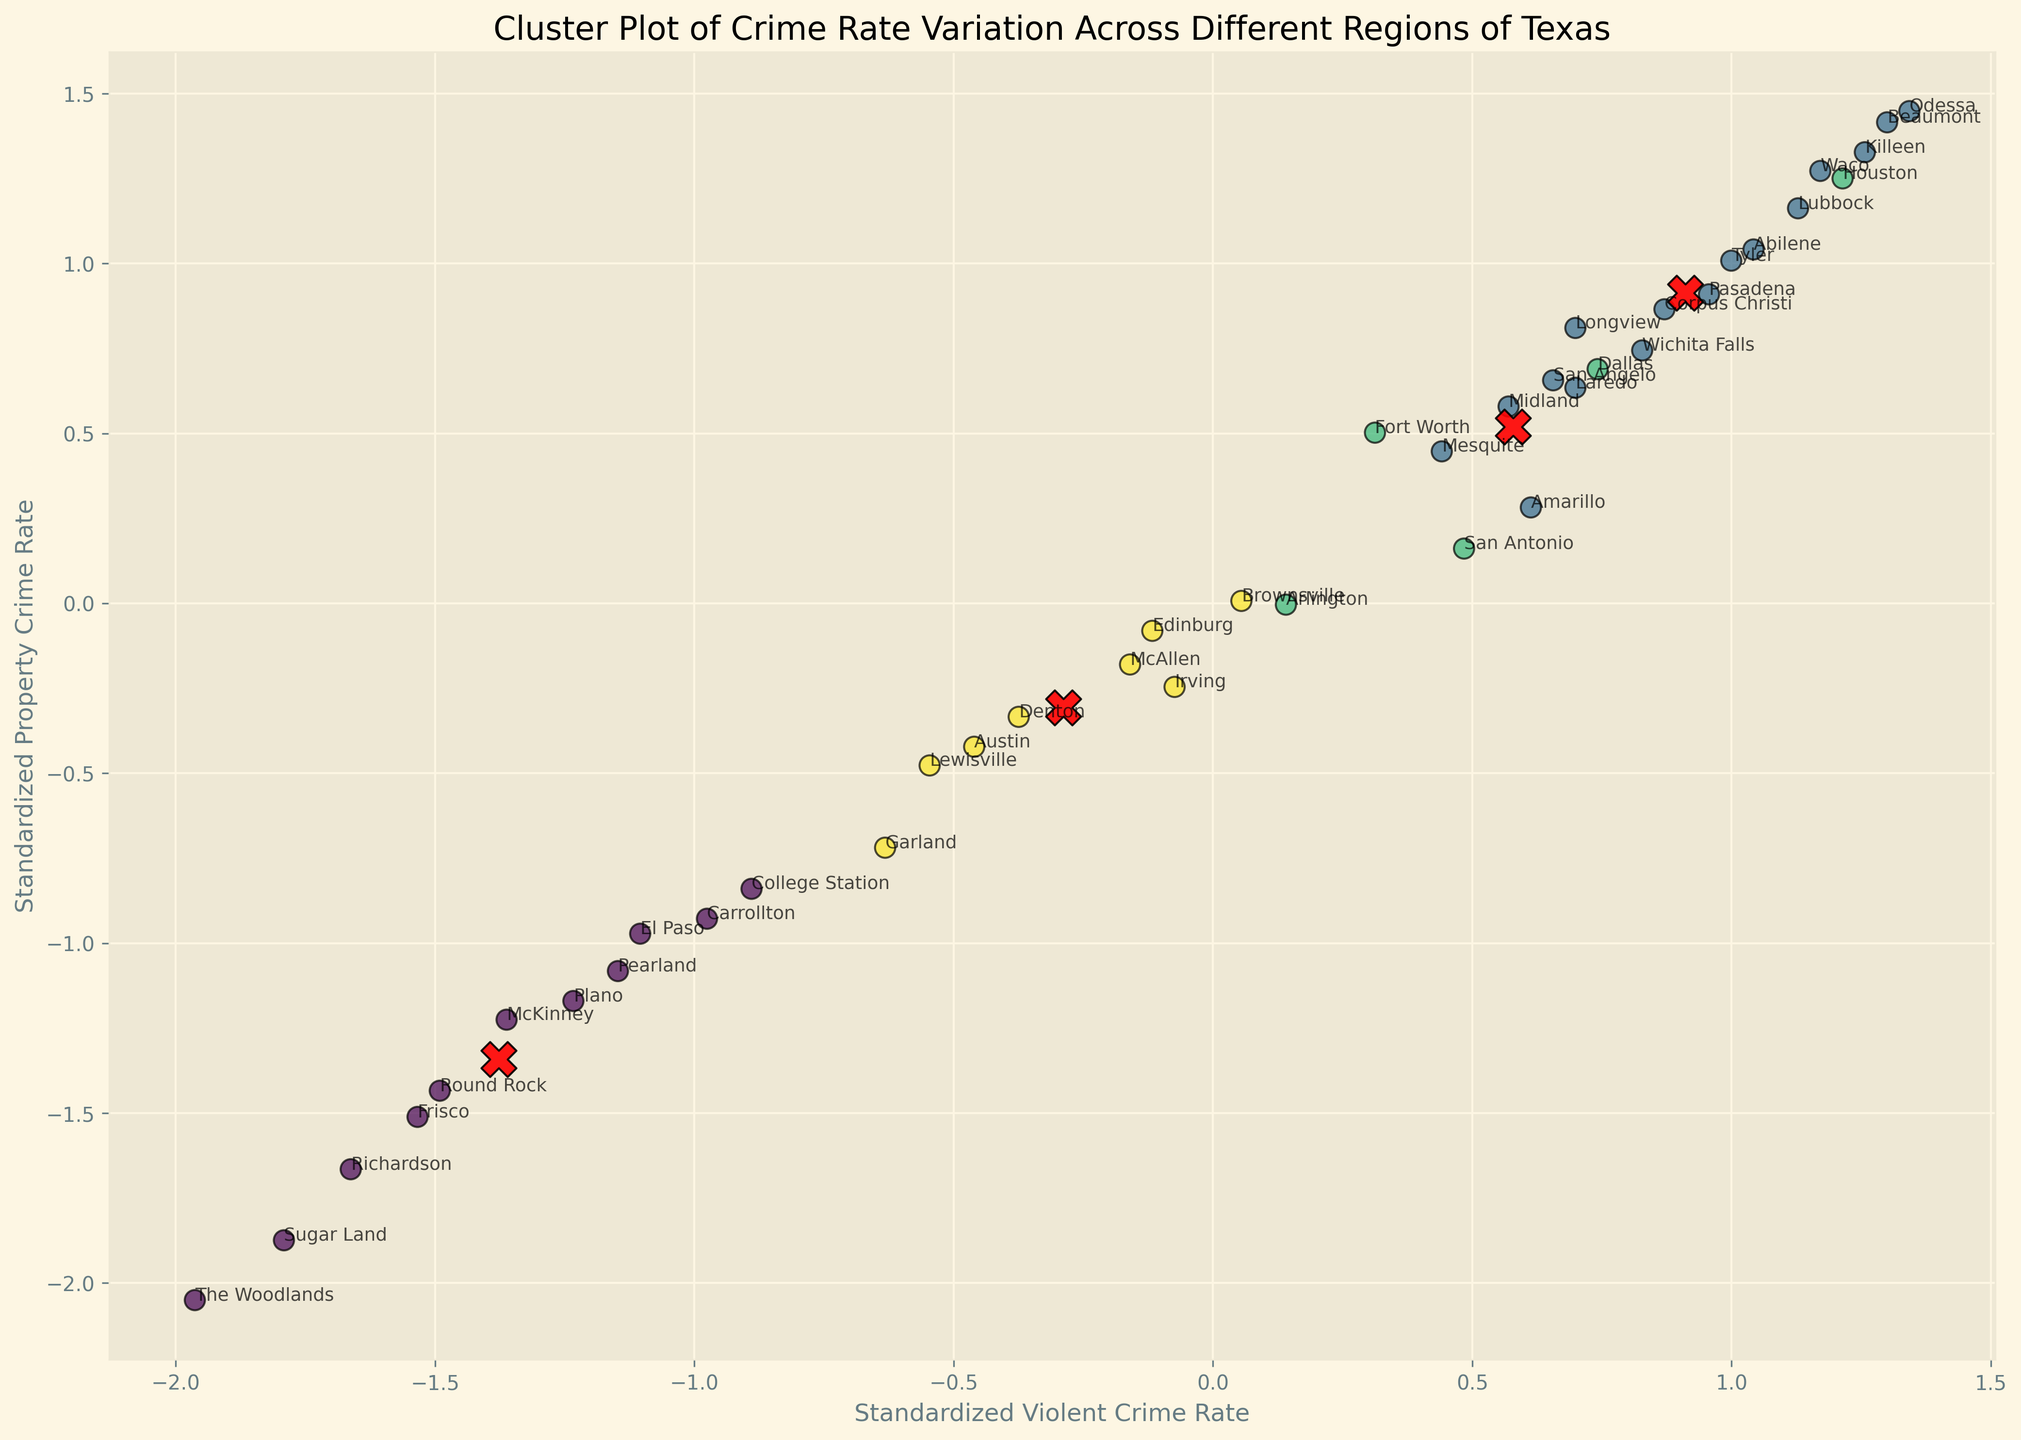Which region has the highest standardized violent crime rate? Look for the point that is furthest to the right on the x-axis, as the x-axis represents the standardized violent crime rate. Check the label of that point.
Answer: Odessa Which cluster has the smallest number of regions? Count the number of points in each cluster indicated by different colors. Identify the color with the least number of points.
Answer: The smallest cluster has 7 regions Is Dallas in the same cluster as Houston? Check the colors of the points labeled Dallas and Houston. If they are the same color, they are in the same cluster.
Answer: Yes Which region lies closest to the cluster centers? Identify and locate the red X markers representing cluster centers. Observe which region points are nearest to these centers.
Answer: Mesquite What's the average standardized property crime rate for regions in the cluster containing Dallas? Identify all regions in the same cluster as Dallas by checking the color of the point labeled Dallas, sum their y-values (standardized property crime rates), and divide by the number of regions.
Answer: Average y-value of Dallas cluster regions Does Austin have a higher standardized property crime rate than San Antonio? Compare the y-values of the points labeled Austin and San Antonio on the plot. The higher y-value indicates a higher standardized property crime rate.
Answer: No Which region has the lowest standardized drug crime rate? Identify the point with the lowest value on the z-axis. Since the plot is 2D, refer to labels to determine the standardized drug crime rate for each region.
Answer: The Woodlands Do regions with lower law enforcement funding generally appear in the same cluster? Identify the clusters based on color and check the law enforcement funding values for regions within these clusters to determine if regions with lower funding are grouped together.
Answer: Generally, yes What is the sum of the standardized violent crime rate and property crime rate for Corpus Christi? Locate the point labeled Corpus Christi and sum its x and y values (Standardized violent and property crime rates).
Answer: x-value + y-value of Corpus Christi Are there more regions in the cluster with the highest center or the cluster with the second highest center? Compare the number of points in the clusters with the highest and second highest red X markers, indicating the highest and second highest cluster centers.
Answer: The cluster with the second highest center has more regions 